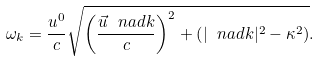<formula> <loc_0><loc_0><loc_500><loc_500>\omega _ { k } = \frac { u ^ { 0 } } { c } \sqrt { \left ( \frac { \vec { u } \ n a d { k } } { c } \right ) ^ { 2 } + \left ( | \ n a d { k } | ^ { 2 } - \kappa ^ { 2 } \right ) } .</formula> 